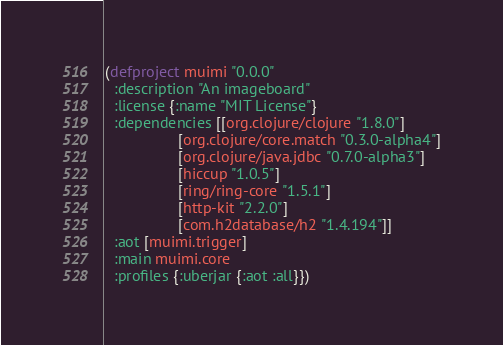Convert code to text. <code><loc_0><loc_0><loc_500><loc_500><_Clojure_>(defproject muimi "0.0.0"
  :description "An imageboard"
  :license {:name "MIT License"}
  :dependencies [[org.clojure/clojure "1.8.0"]
                 [org.clojure/core.match "0.3.0-alpha4"]
                 [org.clojure/java.jdbc "0.7.0-alpha3"]
                 [hiccup "1.0.5"]
                 [ring/ring-core "1.5.1"]
                 [http-kit "2.2.0"]
                 [com.h2database/h2 "1.4.194"]]
  :aot [muimi.trigger]
  :main muimi.core
  :profiles {:uberjar {:aot :all}})
</code> 